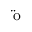Convert formula to latex. <formula><loc_0><loc_0><loc_500><loc_500>\ddot { o }</formula> 